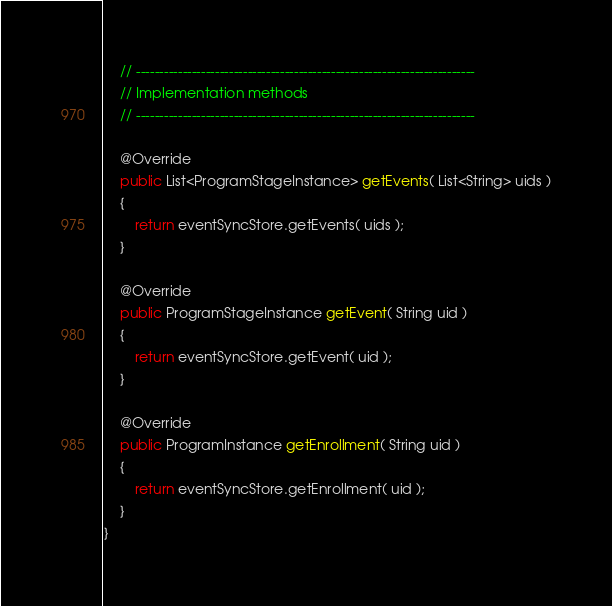Convert code to text. <code><loc_0><loc_0><loc_500><loc_500><_Java_>
    // -------------------------------------------------------------------------
    // Implementation methods
    // -------------------------------------------------------------------------
    
    @Override
    public List<ProgramStageInstance> getEvents( List<String> uids )
    {
        return eventSyncStore.getEvents( uids );
    }

    @Override
    public ProgramStageInstance getEvent( String uid )
    {
        return eventSyncStore.getEvent( uid );
    }

    @Override
    public ProgramInstance getEnrollment( String uid )
    {
        return eventSyncStore.getEnrollment( uid );
    }
}</code> 